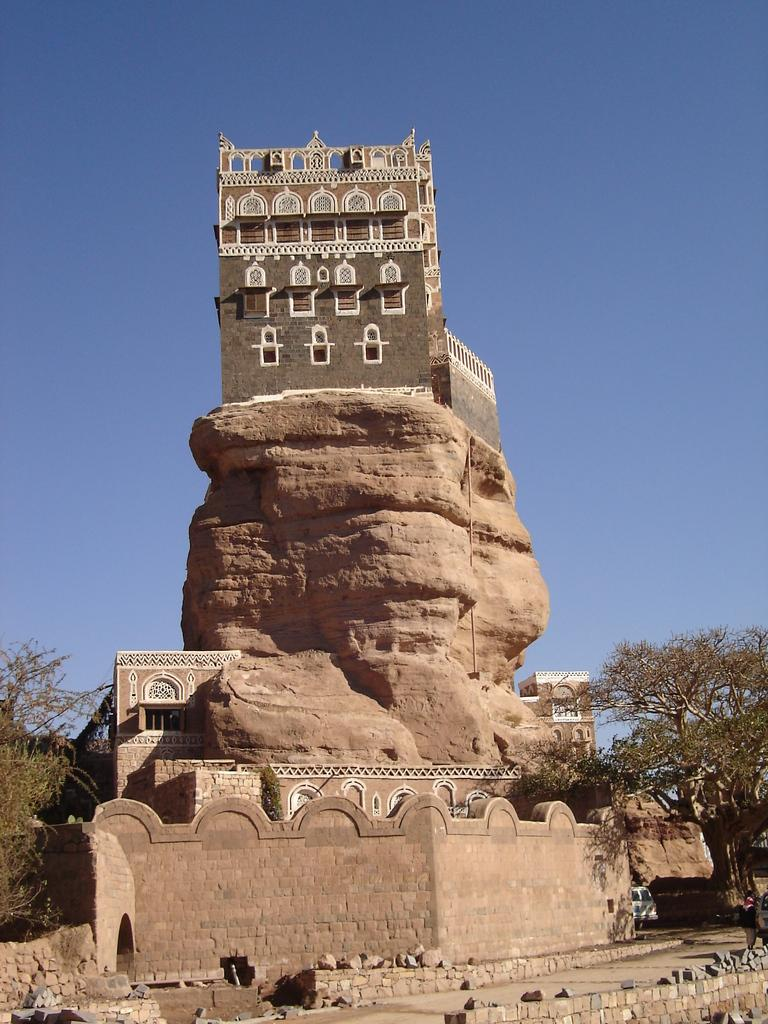What type of structure is in the image? There is a fort in the image. What material is used to build the wall of the fort? The wall of the fort is made up of rocks. What can be seen on either side of the fort? There are trees to the left and right of the fort. What is visible at the top of the image? The sky is visible at the top of the image. How much debt does the fort have in the image? There is no information about the fort's debt in the image, as it is a physical structure and not a financial entity. 